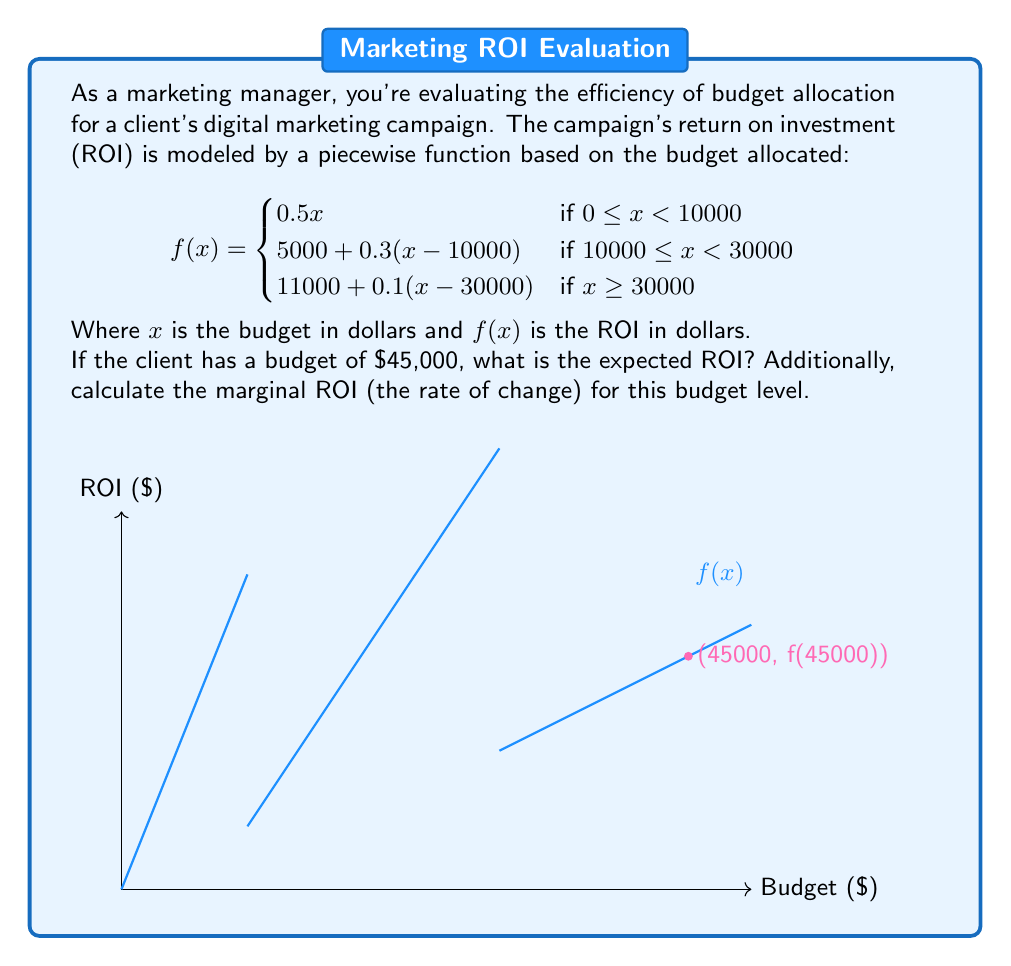Could you help me with this problem? Let's approach this step-by-step:

1) First, we need to determine which piece of the function applies to our budget of $45,000.
   Since $45,000 \geq 30000$, we'll use the third piece of the function:
   
   $$f(x) = 11000 + 0.1(x - 30000)$$

2) Now, let's calculate the ROI by plugging in $x = 45000$:

   $$\begin{align}
   f(45000) &= 11000 + 0.1(45000 - 30000) \\
   &= 11000 + 0.1(15000) \\
   &= 11000 + 1500 \\
   &= 12500
   \end{align}$$

3) To calculate the marginal ROI, we need to find the rate of change at this budget level.
   In a piecewise function, the marginal ROI is the slope of the current piece.
   For $x \geq 30000$, the slope is the coefficient of $x$, which is 0.1.

4) This means that for every additional dollar spent beyond $30,000, the ROI increases by $0.10.

Therefore, at a budget of $45,000:
- The expected ROI is $12,500
- The marginal ROI is $0.10 per additional dollar spent
Answer: ROI: $12,500; Marginal ROI: $0.10 per dollar 